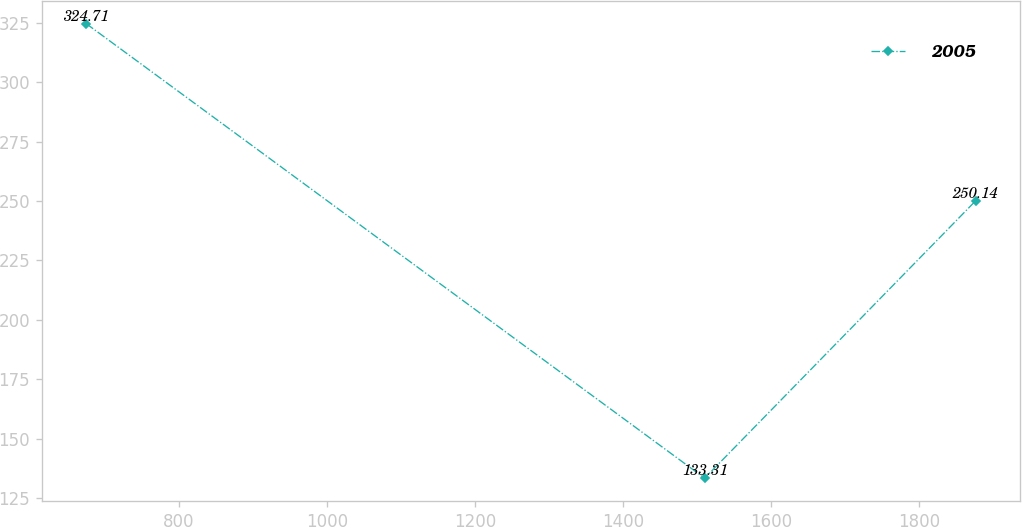<chart> <loc_0><loc_0><loc_500><loc_500><line_chart><ecel><fcel>2005<nl><fcel>674.57<fcel>324.71<nl><fcel>1510.58<fcel>133.31<nl><fcel>1877.03<fcel>250.14<nl></chart> 